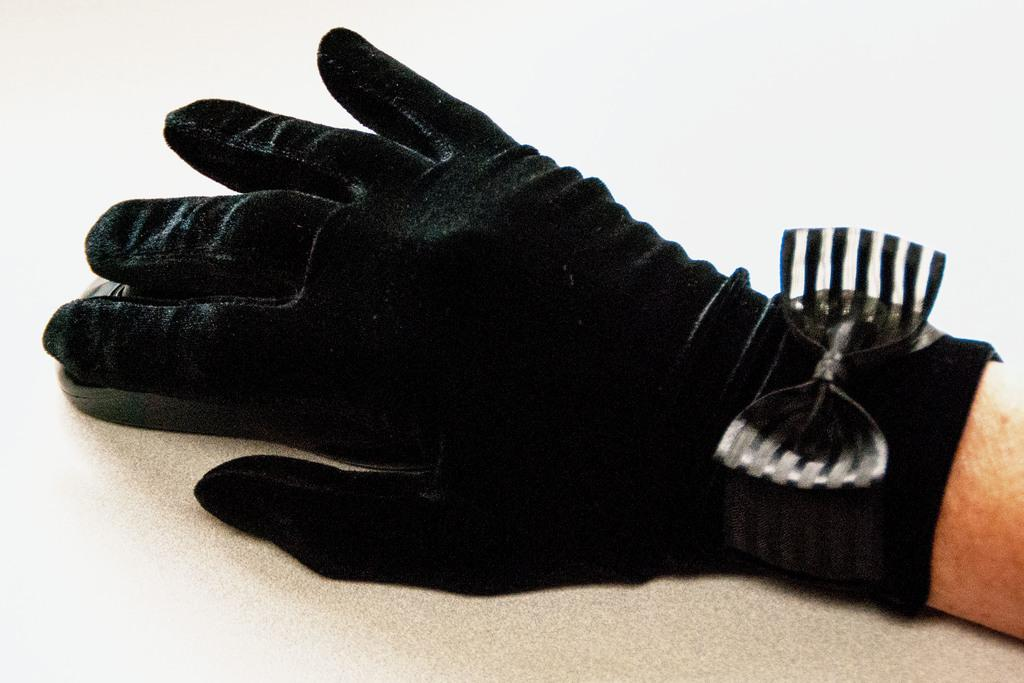What part of a person's body is visible in the image? There is a person's hand in the image. What is the hand wearing? The hand is wearing gloves. What object is the hand placed on? The hand is placed on a mouse. What type of hose is connected to the mouse in the image? There is no hose connected to the mouse in the image. What position is the person's hand in while holding the mouse? The facts provided do not give information about the position of the hand. What type of pancake is being used as a mouse pad in the image? There is no pancake present in the image. 